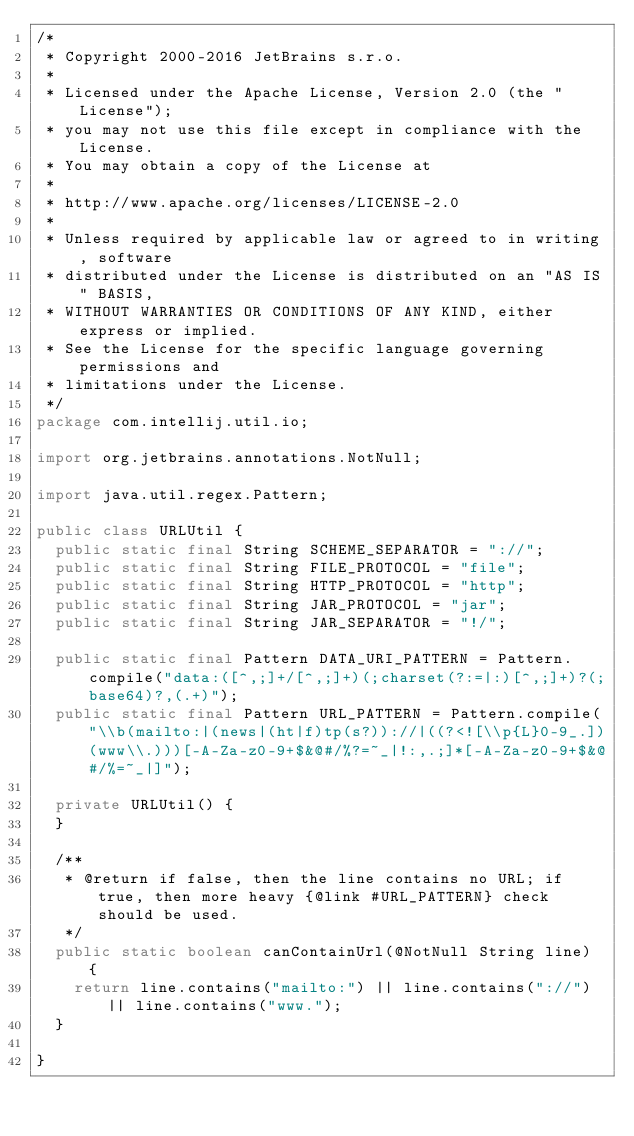<code> <loc_0><loc_0><loc_500><loc_500><_Java_>/*
 * Copyright 2000-2016 JetBrains s.r.o.
 *
 * Licensed under the Apache License, Version 2.0 (the "License");
 * you may not use this file except in compliance with the License.
 * You may obtain a copy of the License at
 *
 * http://www.apache.org/licenses/LICENSE-2.0
 *
 * Unless required by applicable law or agreed to in writing, software
 * distributed under the License is distributed on an "AS IS" BASIS,
 * WITHOUT WARRANTIES OR CONDITIONS OF ANY KIND, either express or implied.
 * See the License for the specific language governing permissions and
 * limitations under the License.
 */
package com.intellij.util.io;

import org.jetbrains.annotations.NotNull;

import java.util.regex.Pattern;

public class URLUtil {
  public static final String SCHEME_SEPARATOR = "://";
  public static final String FILE_PROTOCOL = "file";
  public static final String HTTP_PROTOCOL = "http";
  public static final String JAR_PROTOCOL = "jar";
  public static final String JAR_SEPARATOR = "!/";

  public static final Pattern DATA_URI_PATTERN = Pattern.compile("data:([^,;]+/[^,;]+)(;charset(?:=|:)[^,;]+)?(;base64)?,(.+)");
  public static final Pattern URL_PATTERN = Pattern.compile("\\b(mailto:|(news|(ht|f)tp(s?))://|((?<![\\p{L}0-9_.])(www\\.)))[-A-Za-z0-9+$&@#/%?=~_|!:,.;]*[-A-Za-z0-9+$&@#/%=~_|]");

  private URLUtil() {
  }

  /**
   * @return if false, then the line contains no URL; if true, then more heavy {@link #URL_PATTERN} check should be used.
   */
  public static boolean canContainUrl(@NotNull String line) {
    return line.contains("mailto:") || line.contains("://") || line.contains("www.");
  }

}
</code> 